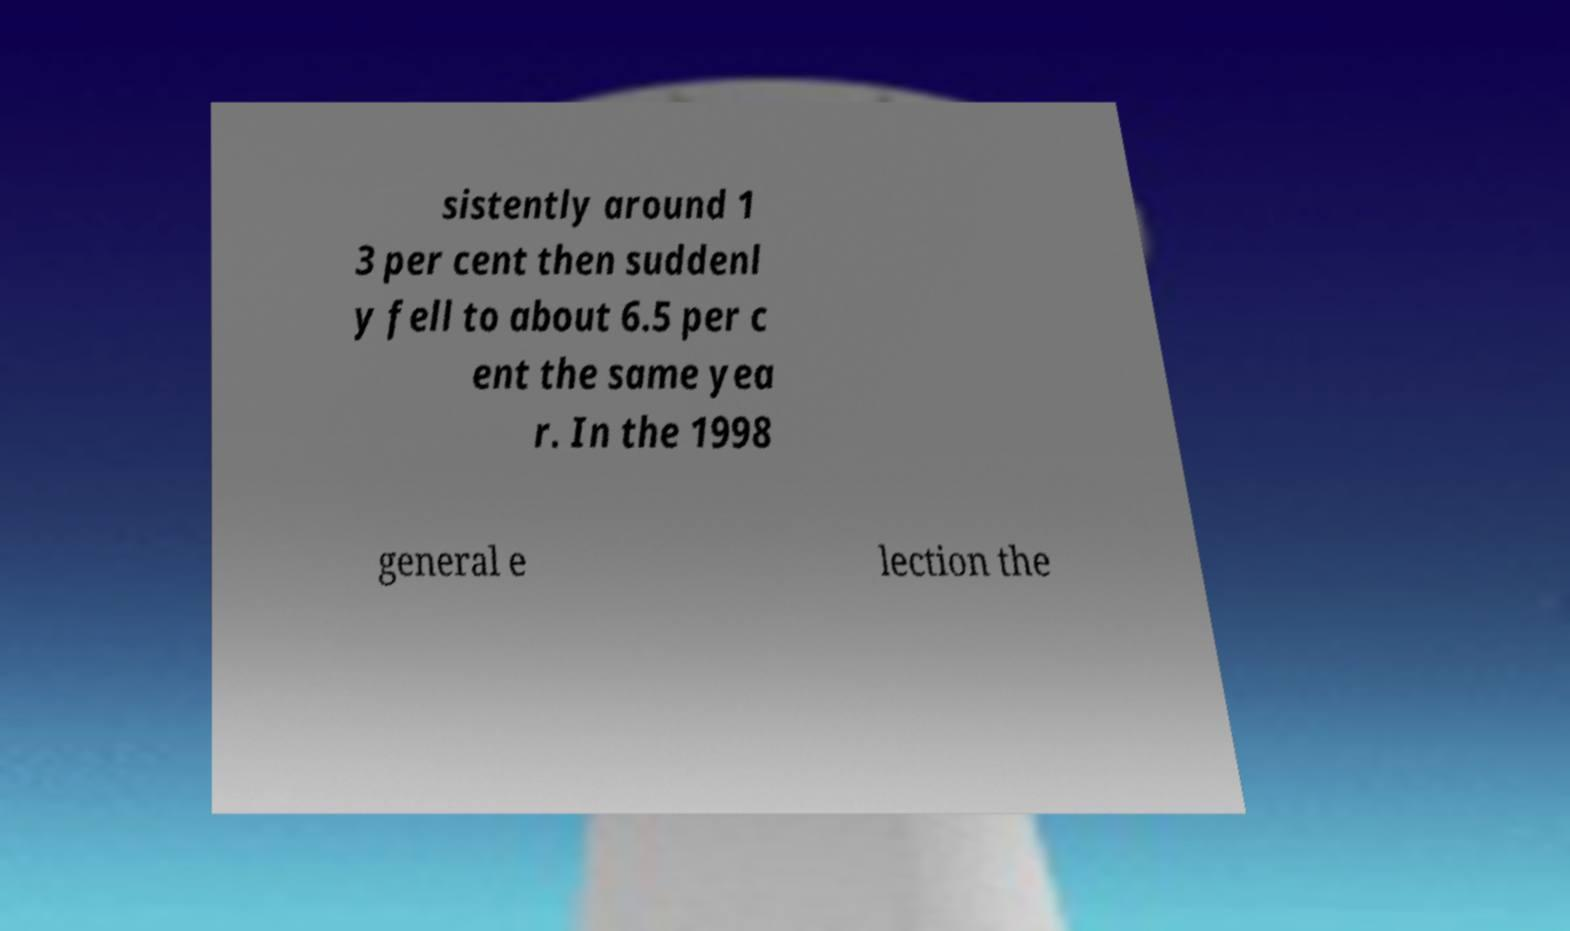Could you extract and type out the text from this image? sistently around 1 3 per cent then suddenl y fell to about 6.5 per c ent the same yea r. In the 1998 general e lection the 